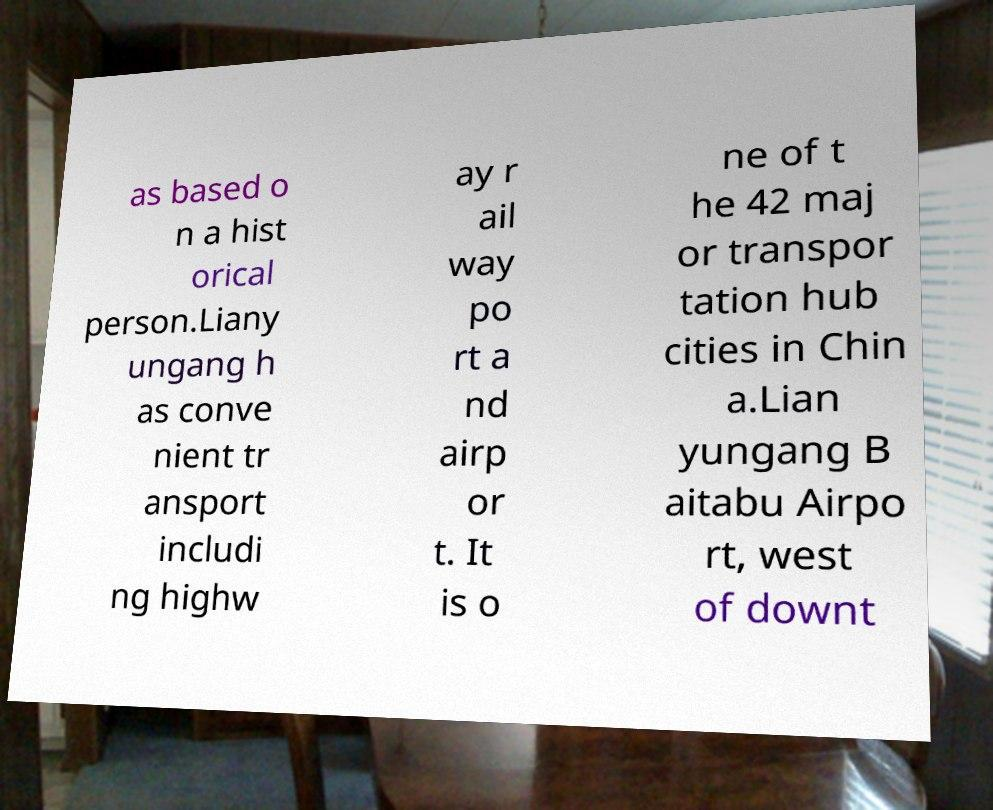Can you read and provide the text displayed in the image?This photo seems to have some interesting text. Can you extract and type it out for me? as based o n a hist orical person.Liany ungang h as conve nient tr ansport includi ng highw ay r ail way po rt a nd airp or t. It is o ne of t he 42 maj or transpor tation hub cities in Chin a.Lian yungang B aitabu Airpo rt, west of downt 